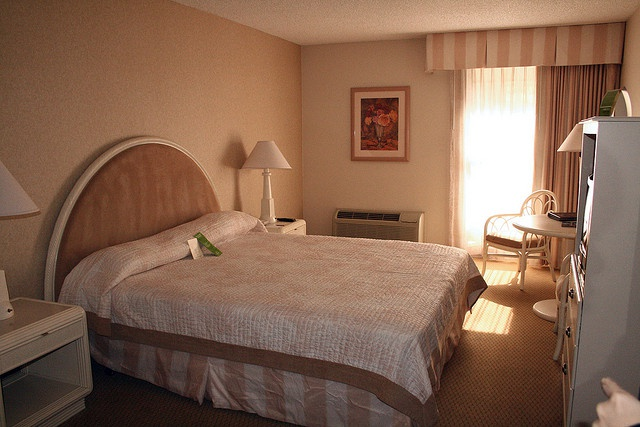Describe the objects in this image and their specific colors. I can see bed in maroon, gray, and tan tones, chair in maroon, ivory, gray, tan, and brown tones, people in maroon, tan, and gray tones, dining table in maroon, gray, white, black, and tan tones, and chair in maroon, brown, and gray tones in this image. 